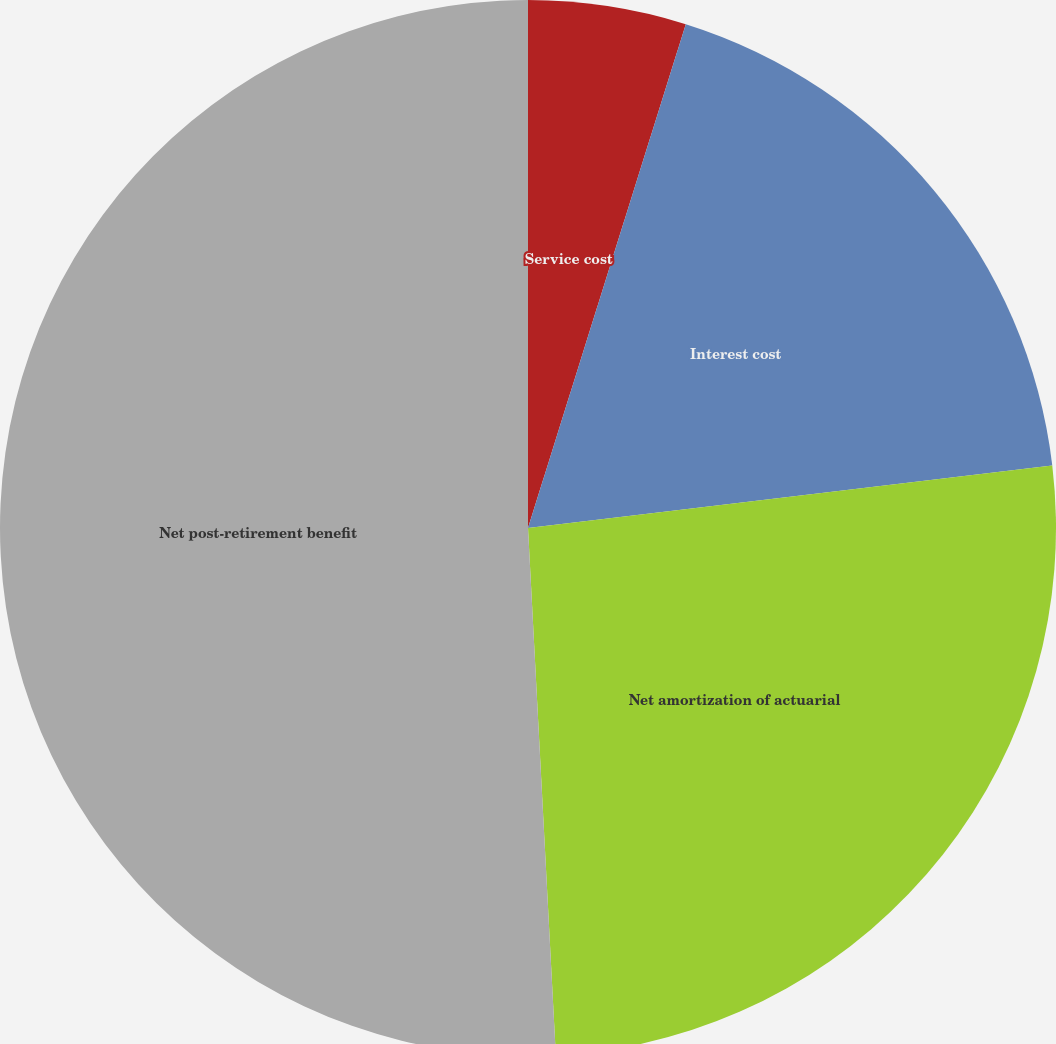Convert chart. <chart><loc_0><loc_0><loc_500><loc_500><pie_chart><fcel>Service cost<fcel>Interest cost<fcel>Net amortization of actuarial<fcel>Net post-retirement benefit<nl><fcel>4.83%<fcel>18.28%<fcel>26.05%<fcel>50.84%<nl></chart> 